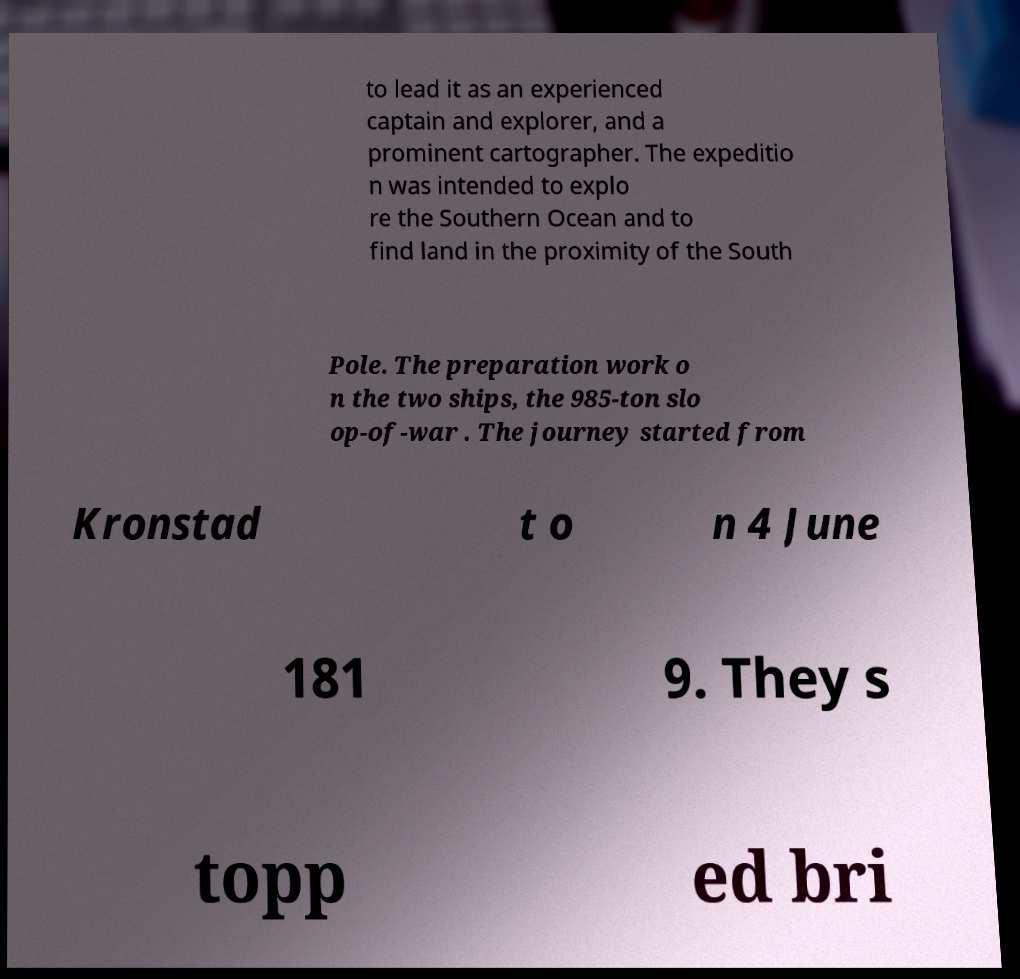Please identify and transcribe the text found in this image. to lead it as an experienced captain and explorer, and a prominent cartographer. The expeditio n was intended to explo re the Southern Ocean and to find land in the proximity of the South Pole. The preparation work o n the two ships, the 985-ton slo op-of-war . The journey started from Kronstad t o n 4 June 181 9. They s topp ed bri 